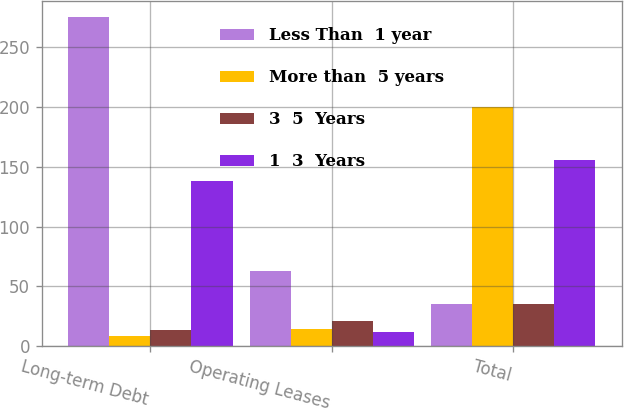Convert chart. <chart><loc_0><loc_0><loc_500><loc_500><stacked_bar_chart><ecel><fcel>Long-term Debt<fcel>Operating Leases<fcel>Total<nl><fcel>Less Than  1 year<fcel>275.1<fcel>62.9<fcel>35.2<nl><fcel>More than  5 years<fcel>8.6<fcel>14.4<fcel>199.6<nl><fcel>3  5  Years<fcel>13.8<fcel>20.7<fcel>35.2<nl><fcel>1  3  Years<fcel>138.2<fcel>11.6<fcel>155.8<nl></chart> 